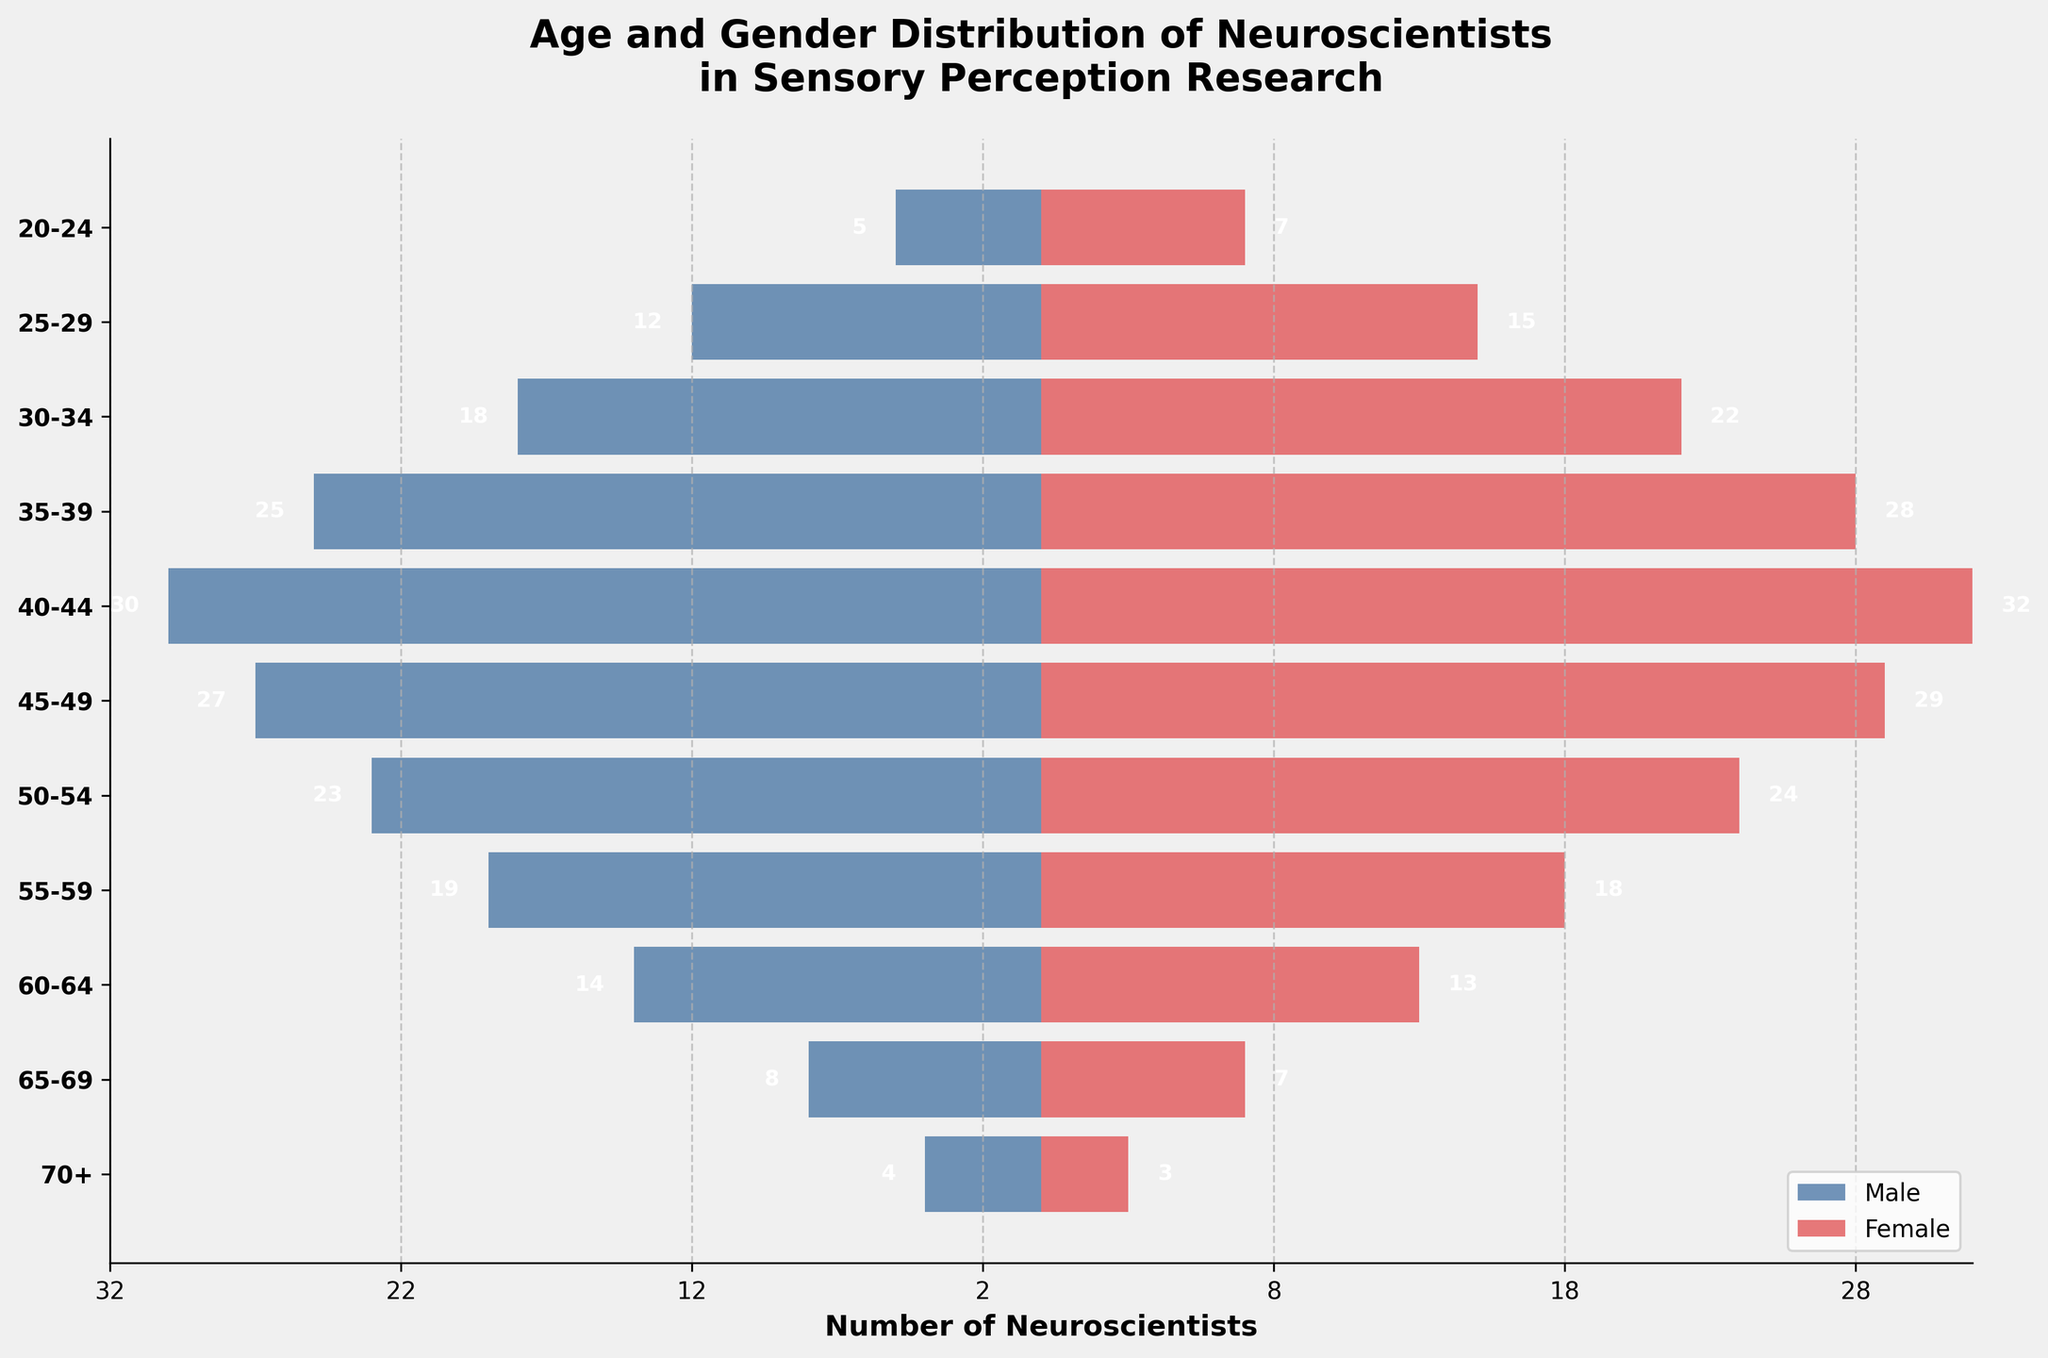What is the age group with the highest number of male neuroscientists? By looking at the male side of the pyramid, we find that the age group with the highest bar length is 40-44, which is 30.
Answer: 40-44 How many female neuroscientists are there in the age group 30-34? By locating the bar corresponding to the age group 30-34 for females, we see that its value is 22.
Answer: 22 Compare the number of male and female neuroscientists in the age group 50-54. Who are more and by how much? The bar for male neuroscientists in the 50-54 group shows 23 while the female bar shows 24. Therefore, there is 1 more female neuroscientist in this age group than males.
Answer: Female, by 1 How many male and female neuroscientists are there in total in the age group 55-59? By adding the values for males and females in the age group 55-59, we get 19 (males) + 18 (females) = 37.
Answer: 37 What's the gender distribution like for early-career neuroscientists (20-24 and 25-29)? By adding up the values for each gender in both age groups, we get:  
Males: 5 (20-24) + 12 (25-29) = 17  
Females: 7 (20-24) + 15 (25-29) = 22
Answer: 17 males, 22 females Identify the overall trend in the gender distribution of neuroscientists as they age. By visually assessing the bars for males and females, males start in lower numbers in early age groups, increase and peak around 40-44, and then decrease steadily. Similarly, females also start lower, peak around 40-44, and then decline. However, females generally have fewer discrepancies across age groups compared to males.
Answer: Both genders peak around 40-44 and then decline How does the number of male neuroscientists in the age group 40-44 compare to the total number of male neuroscientists in the 20-29 age range? The number of male neuroscientists in the age group 40-44 is 30. The total number of male neuroscientists in the 20-29 age range is 5 (20-24) + 12 (25-29) = 17. Therefore, there are 13 more male neuroscientists in 40-44 than in 20-29.
Answer: 13 more in 40-44 What's the gender ratio in the age group 65-69? The number of males is 8, and the number of females is 7. The gender ratio (Male:Female) is 8:7.
Answer: 8:7 